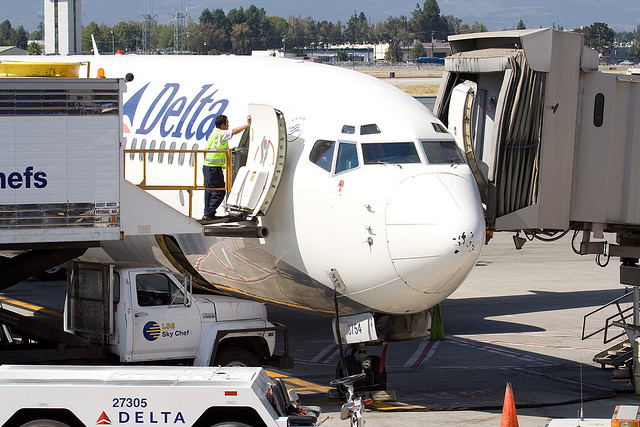Read and extract the text from this image. Delta efs Sky Chat 27305 DELTA 8754 